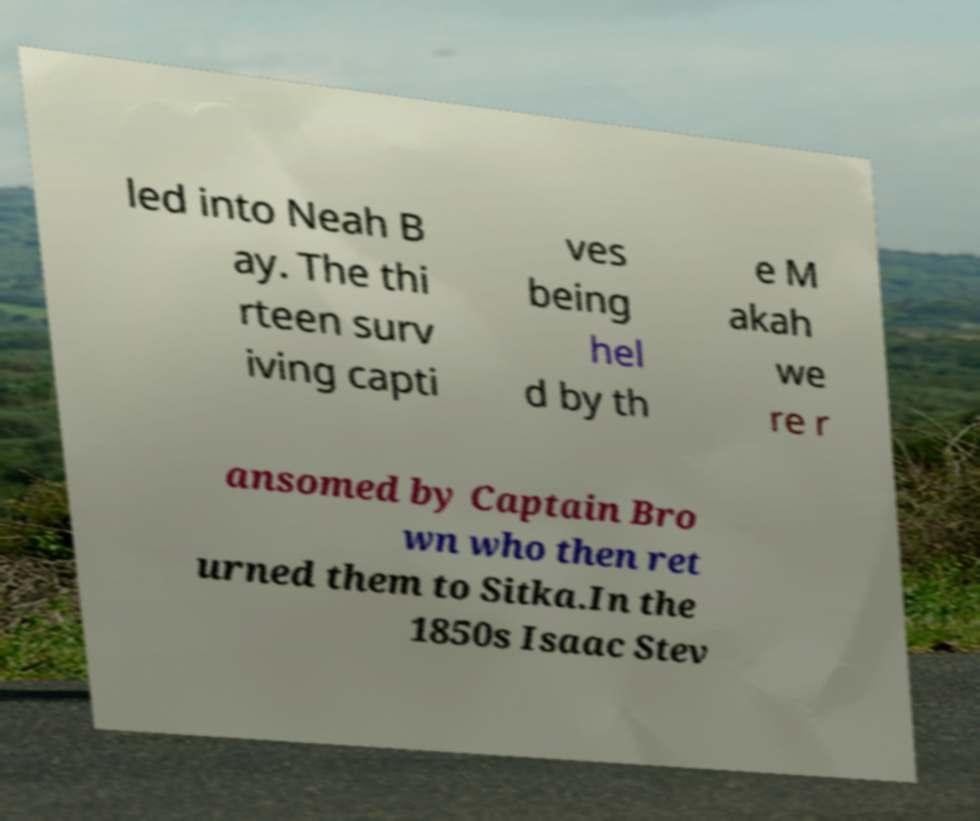Please identify and transcribe the text found in this image. led into Neah B ay. The thi rteen surv iving capti ves being hel d by th e M akah we re r ansomed by Captain Bro wn who then ret urned them to Sitka.In the 1850s Isaac Stev 